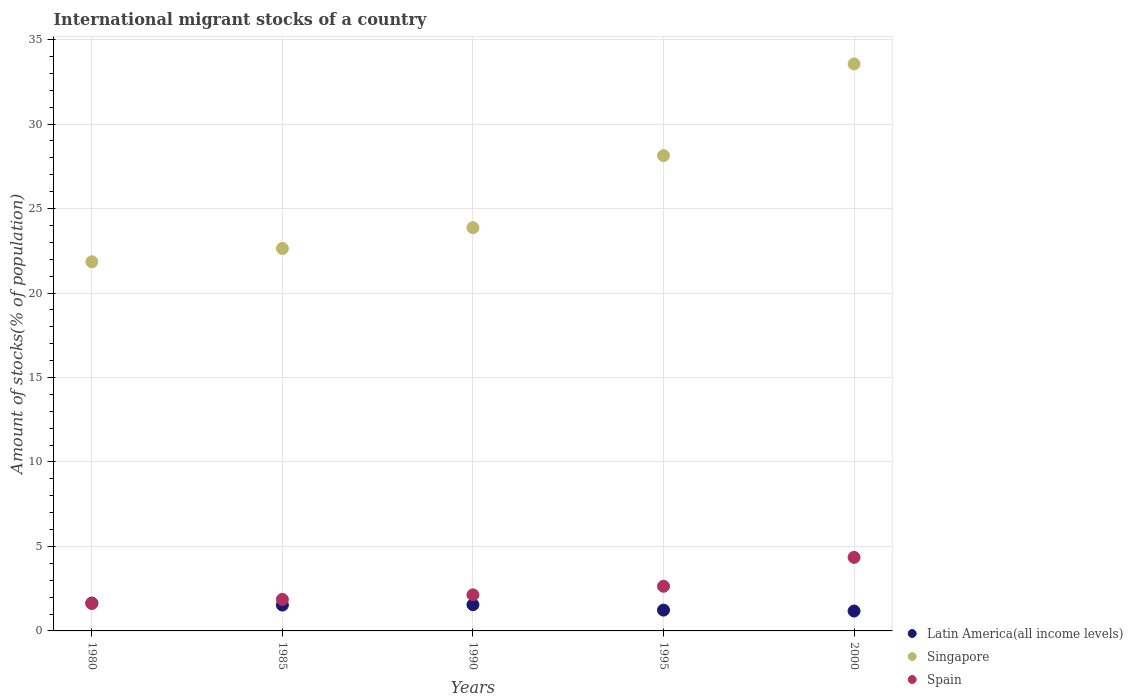Is the number of dotlines equal to the number of legend labels?
Provide a short and direct response. Yes. What is the amount of stocks in in Latin America(all income levels) in 1990?
Your answer should be compact. 1.55. Across all years, what is the maximum amount of stocks in in Spain?
Make the answer very short. 4.35. Across all years, what is the minimum amount of stocks in in Spain?
Make the answer very short. 1.63. In which year was the amount of stocks in in Singapore maximum?
Ensure brevity in your answer.  2000. In which year was the amount of stocks in in Latin America(all income levels) minimum?
Provide a short and direct response. 2000. What is the total amount of stocks in in Singapore in the graph?
Keep it short and to the point. 130.05. What is the difference between the amount of stocks in in Singapore in 1990 and that in 1995?
Your response must be concise. -4.26. What is the difference between the amount of stocks in in Spain in 1995 and the amount of stocks in in Latin America(all income levels) in 1990?
Ensure brevity in your answer.  1.09. What is the average amount of stocks in in Latin America(all income levels) per year?
Your response must be concise. 1.43. In the year 1995, what is the difference between the amount of stocks in in Spain and amount of stocks in in Latin America(all income levels)?
Provide a succinct answer. 1.41. What is the ratio of the amount of stocks in in Latin America(all income levels) in 1995 to that in 2000?
Your answer should be very brief. 1.05. Is the amount of stocks in in Singapore in 1990 less than that in 2000?
Ensure brevity in your answer.  Yes. What is the difference between the highest and the second highest amount of stocks in in Spain?
Your answer should be very brief. 1.71. What is the difference between the highest and the lowest amount of stocks in in Latin America(all income levels)?
Make the answer very short. 0.47. In how many years, is the amount of stocks in in Singapore greater than the average amount of stocks in in Singapore taken over all years?
Offer a very short reply. 2. Does the amount of stocks in in Latin America(all income levels) monotonically increase over the years?
Offer a terse response. No. How many years are there in the graph?
Your answer should be compact. 5. What is the difference between two consecutive major ticks on the Y-axis?
Give a very brief answer. 5. Does the graph contain any zero values?
Your response must be concise. No. How many legend labels are there?
Provide a succinct answer. 3. How are the legend labels stacked?
Keep it short and to the point. Vertical. What is the title of the graph?
Give a very brief answer. International migrant stocks of a country. What is the label or title of the Y-axis?
Provide a short and direct response. Amount of stocks(% of population). What is the Amount of stocks(% of population) in Latin America(all income levels) in 1980?
Offer a terse response. 1.65. What is the Amount of stocks(% of population) of Singapore in 1980?
Offer a terse response. 21.85. What is the Amount of stocks(% of population) in Spain in 1980?
Your response must be concise. 1.63. What is the Amount of stocks(% of population) in Latin America(all income levels) in 1985?
Provide a short and direct response. 1.53. What is the Amount of stocks(% of population) of Singapore in 1985?
Your answer should be compact. 22.64. What is the Amount of stocks(% of population) of Spain in 1985?
Ensure brevity in your answer.  1.87. What is the Amount of stocks(% of population) in Latin America(all income levels) in 1990?
Make the answer very short. 1.55. What is the Amount of stocks(% of population) in Singapore in 1990?
Give a very brief answer. 23.87. What is the Amount of stocks(% of population) in Spain in 1990?
Ensure brevity in your answer.  2.14. What is the Amount of stocks(% of population) of Latin America(all income levels) in 1995?
Give a very brief answer. 1.23. What is the Amount of stocks(% of population) of Singapore in 1995?
Offer a terse response. 28.13. What is the Amount of stocks(% of population) of Spain in 1995?
Keep it short and to the point. 2.64. What is the Amount of stocks(% of population) of Latin America(all income levels) in 2000?
Your response must be concise. 1.18. What is the Amount of stocks(% of population) in Singapore in 2000?
Offer a terse response. 33.56. What is the Amount of stocks(% of population) in Spain in 2000?
Offer a very short reply. 4.35. Across all years, what is the maximum Amount of stocks(% of population) of Latin America(all income levels)?
Make the answer very short. 1.65. Across all years, what is the maximum Amount of stocks(% of population) in Singapore?
Provide a succinct answer. 33.56. Across all years, what is the maximum Amount of stocks(% of population) of Spain?
Give a very brief answer. 4.35. Across all years, what is the minimum Amount of stocks(% of population) of Latin America(all income levels)?
Provide a succinct answer. 1.18. Across all years, what is the minimum Amount of stocks(% of population) of Singapore?
Give a very brief answer. 21.85. Across all years, what is the minimum Amount of stocks(% of population) in Spain?
Ensure brevity in your answer.  1.63. What is the total Amount of stocks(% of population) of Latin America(all income levels) in the graph?
Ensure brevity in your answer.  7.14. What is the total Amount of stocks(% of population) of Singapore in the graph?
Provide a succinct answer. 130.05. What is the total Amount of stocks(% of population) in Spain in the graph?
Ensure brevity in your answer.  12.63. What is the difference between the Amount of stocks(% of population) of Latin America(all income levels) in 1980 and that in 1985?
Give a very brief answer. 0.12. What is the difference between the Amount of stocks(% of population) of Singapore in 1980 and that in 1985?
Your answer should be compact. -0.79. What is the difference between the Amount of stocks(% of population) of Spain in 1980 and that in 1985?
Keep it short and to the point. -0.24. What is the difference between the Amount of stocks(% of population) in Latin America(all income levels) in 1980 and that in 1990?
Provide a succinct answer. 0.1. What is the difference between the Amount of stocks(% of population) of Singapore in 1980 and that in 1990?
Your response must be concise. -2.02. What is the difference between the Amount of stocks(% of population) of Spain in 1980 and that in 1990?
Your answer should be compact. -0.51. What is the difference between the Amount of stocks(% of population) in Latin America(all income levels) in 1980 and that in 1995?
Offer a very short reply. 0.42. What is the difference between the Amount of stocks(% of population) in Singapore in 1980 and that in 1995?
Your response must be concise. -6.28. What is the difference between the Amount of stocks(% of population) of Spain in 1980 and that in 1995?
Provide a succinct answer. -1.02. What is the difference between the Amount of stocks(% of population) in Latin America(all income levels) in 1980 and that in 2000?
Provide a short and direct response. 0.47. What is the difference between the Amount of stocks(% of population) in Singapore in 1980 and that in 2000?
Ensure brevity in your answer.  -11.71. What is the difference between the Amount of stocks(% of population) of Spain in 1980 and that in 2000?
Your answer should be very brief. -2.73. What is the difference between the Amount of stocks(% of population) of Latin America(all income levels) in 1985 and that in 1990?
Your answer should be compact. -0.02. What is the difference between the Amount of stocks(% of population) in Singapore in 1985 and that in 1990?
Ensure brevity in your answer.  -1.23. What is the difference between the Amount of stocks(% of population) of Spain in 1985 and that in 1990?
Your answer should be compact. -0.27. What is the difference between the Amount of stocks(% of population) of Latin America(all income levels) in 1985 and that in 1995?
Your response must be concise. 0.3. What is the difference between the Amount of stocks(% of population) in Singapore in 1985 and that in 1995?
Give a very brief answer. -5.5. What is the difference between the Amount of stocks(% of population) in Spain in 1985 and that in 1995?
Provide a short and direct response. -0.78. What is the difference between the Amount of stocks(% of population) in Latin America(all income levels) in 1985 and that in 2000?
Your answer should be very brief. 0.35. What is the difference between the Amount of stocks(% of population) in Singapore in 1985 and that in 2000?
Offer a terse response. -10.92. What is the difference between the Amount of stocks(% of population) of Spain in 1985 and that in 2000?
Offer a very short reply. -2.49. What is the difference between the Amount of stocks(% of population) in Latin America(all income levels) in 1990 and that in 1995?
Make the answer very short. 0.32. What is the difference between the Amount of stocks(% of population) of Singapore in 1990 and that in 1995?
Your answer should be compact. -4.26. What is the difference between the Amount of stocks(% of population) of Spain in 1990 and that in 1995?
Keep it short and to the point. -0.51. What is the difference between the Amount of stocks(% of population) in Latin America(all income levels) in 1990 and that in 2000?
Give a very brief answer. 0.37. What is the difference between the Amount of stocks(% of population) in Singapore in 1990 and that in 2000?
Offer a very short reply. -9.69. What is the difference between the Amount of stocks(% of population) of Spain in 1990 and that in 2000?
Ensure brevity in your answer.  -2.22. What is the difference between the Amount of stocks(% of population) in Latin America(all income levels) in 1995 and that in 2000?
Offer a very short reply. 0.05. What is the difference between the Amount of stocks(% of population) of Singapore in 1995 and that in 2000?
Your answer should be very brief. -5.43. What is the difference between the Amount of stocks(% of population) of Spain in 1995 and that in 2000?
Your response must be concise. -1.71. What is the difference between the Amount of stocks(% of population) in Latin America(all income levels) in 1980 and the Amount of stocks(% of population) in Singapore in 1985?
Your response must be concise. -20.99. What is the difference between the Amount of stocks(% of population) in Latin America(all income levels) in 1980 and the Amount of stocks(% of population) in Spain in 1985?
Your answer should be compact. -0.22. What is the difference between the Amount of stocks(% of population) in Singapore in 1980 and the Amount of stocks(% of population) in Spain in 1985?
Offer a very short reply. 19.98. What is the difference between the Amount of stocks(% of population) in Latin America(all income levels) in 1980 and the Amount of stocks(% of population) in Singapore in 1990?
Your answer should be compact. -22.22. What is the difference between the Amount of stocks(% of population) of Latin America(all income levels) in 1980 and the Amount of stocks(% of population) of Spain in 1990?
Your answer should be compact. -0.49. What is the difference between the Amount of stocks(% of population) of Singapore in 1980 and the Amount of stocks(% of population) of Spain in 1990?
Ensure brevity in your answer.  19.71. What is the difference between the Amount of stocks(% of population) of Latin America(all income levels) in 1980 and the Amount of stocks(% of population) of Singapore in 1995?
Your answer should be compact. -26.48. What is the difference between the Amount of stocks(% of population) in Latin America(all income levels) in 1980 and the Amount of stocks(% of population) in Spain in 1995?
Your response must be concise. -0.99. What is the difference between the Amount of stocks(% of population) in Singapore in 1980 and the Amount of stocks(% of population) in Spain in 1995?
Keep it short and to the point. 19.21. What is the difference between the Amount of stocks(% of population) in Latin America(all income levels) in 1980 and the Amount of stocks(% of population) in Singapore in 2000?
Your answer should be very brief. -31.91. What is the difference between the Amount of stocks(% of population) in Latin America(all income levels) in 1980 and the Amount of stocks(% of population) in Spain in 2000?
Give a very brief answer. -2.7. What is the difference between the Amount of stocks(% of population) in Singapore in 1980 and the Amount of stocks(% of population) in Spain in 2000?
Provide a short and direct response. 17.5. What is the difference between the Amount of stocks(% of population) of Latin America(all income levels) in 1985 and the Amount of stocks(% of population) of Singapore in 1990?
Keep it short and to the point. -22.34. What is the difference between the Amount of stocks(% of population) of Latin America(all income levels) in 1985 and the Amount of stocks(% of population) of Spain in 1990?
Provide a short and direct response. -0.61. What is the difference between the Amount of stocks(% of population) of Singapore in 1985 and the Amount of stocks(% of population) of Spain in 1990?
Give a very brief answer. 20.5. What is the difference between the Amount of stocks(% of population) of Latin America(all income levels) in 1985 and the Amount of stocks(% of population) of Singapore in 1995?
Your answer should be compact. -26.6. What is the difference between the Amount of stocks(% of population) of Latin America(all income levels) in 1985 and the Amount of stocks(% of population) of Spain in 1995?
Your answer should be compact. -1.11. What is the difference between the Amount of stocks(% of population) of Singapore in 1985 and the Amount of stocks(% of population) of Spain in 1995?
Your response must be concise. 19.99. What is the difference between the Amount of stocks(% of population) of Latin America(all income levels) in 1985 and the Amount of stocks(% of population) of Singapore in 2000?
Your answer should be very brief. -32.03. What is the difference between the Amount of stocks(% of population) of Latin America(all income levels) in 1985 and the Amount of stocks(% of population) of Spain in 2000?
Your response must be concise. -2.82. What is the difference between the Amount of stocks(% of population) in Singapore in 1985 and the Amount of stocks(% of population) in Spain in 2000?
Offer a very short reply. 18.28. What is the difference between the Amount of stocks(% of population) in Latin America(all income levels) in 1990 and the Amount of stocks(% of population) in Singapore in 1995?
Your answer should be very brief. -26.58. What is the difference between the Amount of stocks(% of population) in Latin America(all income levels) in 1990 and the Amount of stocks(% of population) in Spain in 1995?
Offer a very short reply. -1.09. What is the difference between the Amount of stocks(% of population) of Singapore in 1990 and the Amount of stocks(% of population) of Spain in 1995?
Ensure brevity in your answer.  21.23. What is the difference between the Amount of stocks(% of population) of Latin America(all income levels) in 1990 and the Amount of stocks(% of population) of Singapore in 2000?
Make the answer very short. -32.01. What is the difference between the Amount of stocks(% of population) in Latin America(all income levels) in 1990 and the Amount of stocks(% of population) in Spain in 2000?
Ensure brevity in your answer.  -2.8. What is the difference between the Amount of stocks(% of population) of Singapore in 1990 and the Amount of stocks(% of population) of Spain in 2000?
Provide a succinct answer. 19.52. What is the difference between the Amount of stocks(% of population) of Latin America(all income levels) in 1995 and the Amount of stocks(% of population) of Singapore in 2000?
Provide a succinct answer. -32.33. What is the difference between the Amount of stocks(% of population) of Latin America(all income levels) in 1995 and the Amount of stocks(% of population) of Spain in 2000?
Your response must be concise. -3.12. What is the difference between the Amount of stocks(% of population) of Singapore in 1995 and the Amount of stocks(% of population) of Spain in 2000?
Your answer should be very brief. 23.78. What is the average Amount of stocks(% of population) of Latin America(all income levels) per year?
Your answer should be compact. 1.43. What is the average Amount of stocks(% of population) in Singapore per year?
Ensure brevity in your answer.  26.01. What is the average Amount of stocks(% of population) in Spain per year?
Your answer should be compact. 2.53. In the year 1980, what is the difference between the Amount of stocks(% of population) of Latin America(all income levels) and Amount of stocks(% of population) of Singapore?
Ensure brevity in your answer.  -20.2. In the year 1980, what is the difference between the Amount of stocks(% of population) of Latin America(all income levels) and Amount of stocks(% of population) of Spain?
Make the answer very short. 0.02. In the year 1980, what is the difference between the Amount of stocks(% of population) in Singapore and Amount of stocks(% of population) in Spain?
Make the answer very short. 20.22. In the year 1985, what is the difference between the Amount of stocks(% of population) of Latin America(all income levels) and Amount of stocks(% of population) of Singapore?
Ensure brevity in your answer.  -21.11. In the year 1985, what is the difference between the Amount of stocks(% of population) of Latin America(all income levels) and Amount of stocks(% of population) of Spain?
Offer a terse response. -0.34. In the year 1985, what is the difference between the Amount of stocks(% of population) of Singapore and Amount of stocks(% of population) of Spain?
Your answer should be very brief. 20.77. In the year 1990, what is the difference between the Amount of stocks(% of population) of Latin America(all income levels) and Amount of stocks(% of population) of Singapore?
Your answer should be very brief. -22.32. In the year 1990, what is the difference between the Amount of stocks(% of population) in Latin America(all income levels) and Amount of stocks(% of population) in Spain?
Give a very brief answer. -0.58. In the year 1990, what is the difference between the Amount of stocks(% of population) in Singapore and Amount of stocks(% of population) in Spain?
Offer a terse response. 21.73. In the year 1995, what is the difference between the Amount of stocks(% of population) of Latin America(all income levels) and Amount of stocks(% of population) of Singapore?
Give a very brief answer. -26.9. In the year 1995, what is the difference between the Amount of stocks(% of population) in Latin America(all income levels) and Amount of stocks(% of population) in Spain?
Give a very brief answer. -1.41. In the year 1995, what is the difference between the Amount of stocks(% of population) of Singapore and Amount of stocks(% of population) of Spain?
Give a very brief answer. 25.49. In the year 2000, what is the difference between the Amount of stocks(% of population) in Latin America(all income levels) and Amount of stocks(% of population) in Singapore?
Your answer should be very brief. -32.38. In the year 2000, what is the difference between the Amount of stocks(% of population) in Latin America(all income levels) and Amount of stocks(% of population) in Spain?
Your response must be concise. -3.18. In the year 2000, what is the difference between the Amount of stocks(% of population) in Singapore and Amount of stocks(% of population) in Spain?
Your answer should be very brief. 29.21. What is the ratio of the Amount of stocks(% of population) of Latin America(all income levels) in 1980 to that in 1985?
Your response must be concise. 1.08. What is the ratio of the Amount of stocks(% of population) of Singapore in 1980 to that in 1985?
Ensure brevity in your answer.  0.97. What is the ratio of the Amount of stocks(% of population) in Spain in 1980 to that in 1985?
Provide a short and direct response. 0.87. What is the ratio of the Amount of stocks(% of population) of Latin America(all income levels) in 1980 to that in 1990?
Offer a very short reply. 1.06. What is the ratio of the Amount of stocks(% of population) of Singapore in 1980 to that in 1990?
Ensure brevity in your answer.  0.92. What is the ratio of the Amount of stocks(% of population) in Spain in 1980 to that in 1990?
Your answer should be compact. 0.76. What is the ratio of the Amount of stocks(% of population) in Latin America(all income levels) in 1980 to that in 1995?
Offer a terse response. 1.34. What is the ratio of the Amount of stocks(% of population) in Singapore in 1980 to that in 1995?
Your answer should be very brief. 0.78. What is the ratio of the Amount of stocks(% of population) of Spain in 1980 to that in 1995?
Give a very brief answer. 0.62. What is the ratio of the Amount of stocks(% of population) of Latin America(all income levels) in 1980 to that in 2000?
Your response must be concise. 1.4. What is the ratio of the Amount of stocks(% of population) in Singapore in 1980 to that in 2000?
Your answer should be very brief. 0.65. What is the ratio of the Amount of stocks(% of population) in Spain in 1980 to that in 2000?
Offer a very short reply. 0.37. What is the ratio of the Amount of stocks(% of population) in Latin America(all income levels) in 1985 to that in 1990?
Make the answer very short. 0.99. What is the ratio of the Amount of stocks(% of population) in Singapore in 1985 to that in 1990?
Offer a terse response. 0.95. What is the ratio of the Amount of stocks(% of population) of Spain in 1985 to that in 1990?
Your response must be concise. 0.87. What is the ratio of the Amount of stocks(% of population) in Latin America(all income levels) in 1985 to that in 1995?
Ensure brevity in your answer.  1.24. What is the ratio of the Amount of stocks(% of population) of Singapore in 1985 to that in 1995?
Your answer should be very brief. 0.8. What is the ratio of the Amount of stocks(% of population) in Spain in 1985 to that in 1995?
Make the answer very short. 0.71. What is the ratio of the Amount of stocks(% of population) in Latin America(all income levels) in 1985 to that in 2000?
Provide a short and direct response. 1.3. What is the ratio of the Amount of stocks(% of population) of Singapore in 1985 to that in 2000?
Your answer should be very brief. 0.67. What is the ratio of the Amount of stocks(% of population) in Spain in 1985 to that in 2000?
Your answer should be very brief. 0.43. What is the ratio of the Amount of stocks(% of population) in Latin America(all income levels) in 1990 to that in 1995?
Your response must be concise. 1.26. What is the ratio of the Amount of stocks(% of population) in Singapore in 1990 to that in 1995?
Your response must be concise. 0.85. What is the ratio of the Amount of stocks(% of population) of Spain in 1990 to that in 1995?
Make the answer very short. 0.81. What is the ratio of the Amount of stocks(% of population) in Latin America(all income levels) in 1990 to that in 2000?
Your answer should be compact. 1.32. What is the ratio of the Amount of stocks(% of population) of Singapore in 1990 to that in 2000?
Provide a short and direct response. 0.71. What is the ratio of the Amount of stocks(% of population) in Spain in 1990 to that in 2000?
Give a very brief answer. 0.49. What is the ratio of the Amount of stocks(% of population) in Latin America(all income levels) in 1995 to that in 2000?
Your response must be concise. 1.05. What is the ratio of the Amount of stocks(% of population) of Singapore in 1995 to that in 2000?
Your response must be concise. 0.84. What is the ratio of the Amount of stocks(% of population) of Spain in 1995 to that in 2000?
Ensure brevity in your answer.  0.61. What is the difference between the highest and the second highest Amount of stocks(% of population) in Latin America(all income levels)?
Offer a terse response. 0.1. What is the difference between the highest and the second highest Amount of stocks(% of population) of Singapore?
Offer a very short reply. 5.43. What is the difference between the highest and the second highest Amount of stocks(% of population) in Spain?
Your answer should be compact. 1.71. What is the difference between the highest and the lowest Amount of stocks(% of population) of Latin America(all income levels)?
Make the answer very short. 0.47. What is the difference between the highest and the lowest Amount of stocks(% of population) in Singapore?
Provide a succinct answer. 11.71. What is the difference between the highest and the lowest Amount of stocks(% of population) of Spain?
Give a very brief answer. 2.73. 